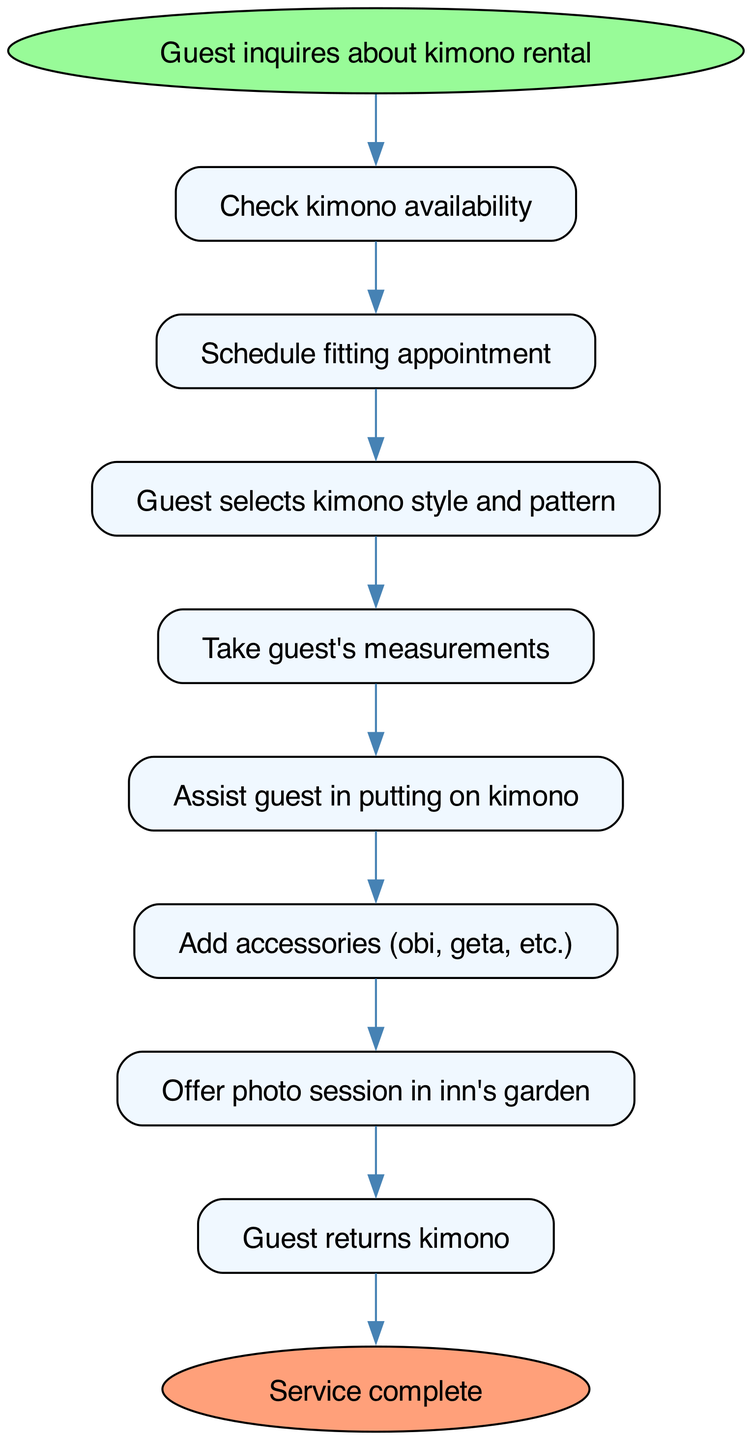What is the first step in the workflow? The flowchart starts with the node labeled "Guest inquires about kimono rental," which indicates the initial action in the process.
Answer: Guest inquires about kimono rental How many edges are there in the diagram? Upon examining the diagram, we can count the lines connecting the nodes (edges), which total nine.
Answer: 9 What step follows after checking kimono availability? After the "Check kimono availability" node, the next step indicated in the flowchart is "Schedule fitting appointment."
Answer: Schedule fitting appointment Which node comes before the "Assist guest in putting on kimono"? The node that precedes "Assist guest in putting on kimono" is "Take guest's measurements." This indicates the order of operations in the workflow.
Answer: Take guest's measurements What is the last action mentioned in the flowchart? The last action described in the flowchart is "Service complete," which signifies the end of the process for the kimono rental and fitting service.
Answer: Service complete What happens before the guest returns the kimono? Prior to the "Guest returns kimono" step, the flowchart shows "Offer photo session in inn's garden." This implies that the guests first participate in a photo session after donning the kimono.
Answer: Offer photo session in inn's garden How many nodes are involved in the fitting service workflow? By counting the individual steps and points in the flowchart, we find there are ten nodes that represent the different stages of the kimono rental process.
Answer: 10 